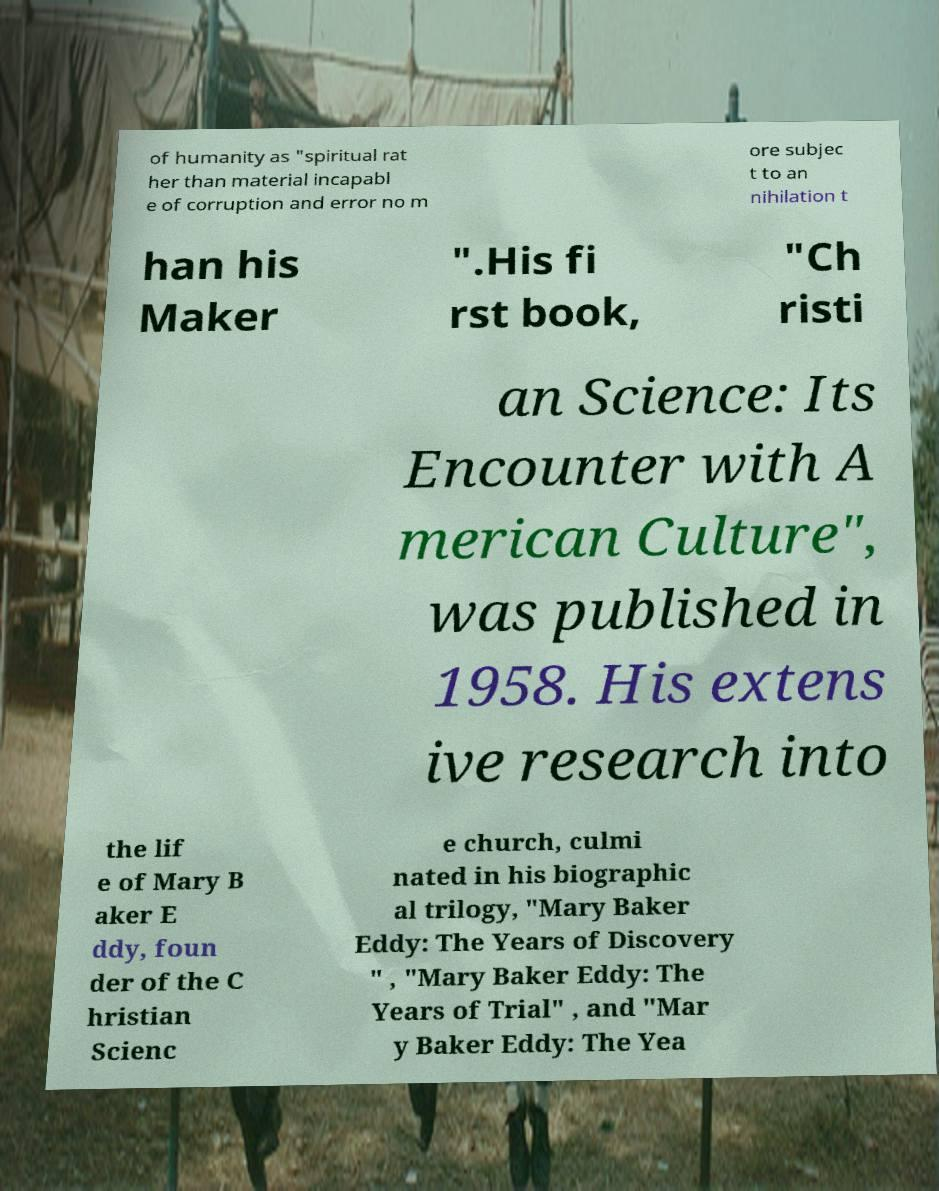Could you assist in decoding the text presented in this image and type it out clearly? of humanity as "spiritual rat her than material incapabl e of corruption and error no m ore subjec t to an nihilation t han his Maker ".His fi rst book, "Ch risti an Science: Its Encounter with A merican Culture", was published in 1958. His extens ive research into the lif e of Mary B aker E ddy, foun der of the C hristian Scienc e church, culmi nated in his biographic al trilogy, "Mary Baker Eddy: The Years of Discovery " , "Mary Baker Eddy: The Years of Trial" , and "Mar y Baker Eddy: The Yea 